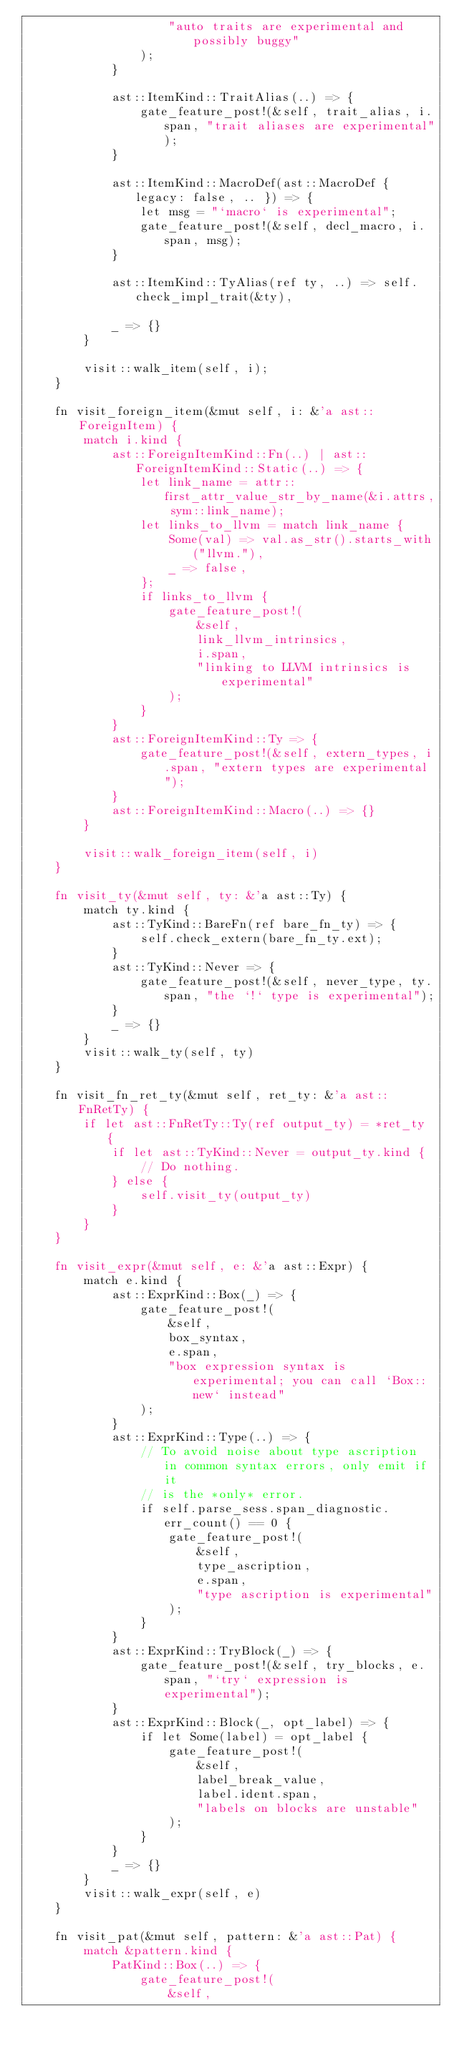Convert code to text. <code><loc_0><loc_0><loc_500><loc_500><_Rust_>                    "auto traits are experimental and possibly buggy"
                );
            }

            ast::ItemKind::TraitAlias(..) => {
                gate_feature_post!(&self, trait_alias, i.span, "trait aliases are experimental");
            }

            ast::ItemKind::MacroDef(ast::MacroDef { legacy: false, .. }) => {
                let msg = "`macro` is experimental";
                gate_feature_post!(&self, decl_macro, i.span, msg);
            }

            ast::ItemKind::TyAlias(ref ty, ..) => self.check_impl_trait(&ty),

            _ => {}
        }

        visit::walk_item(self, i);
    }

    fn visit_foreign_item(&mut self, i: &'a ast::ForeignItem) {
        match i.kind {
            ast::ForeignItemKind::Fn(..) | ast::ForeignItemKind::Static(..) => {
                let link_name = attr::first_attr_value_str_by_name(&i.attrs, sym::link_name);
                let links_to_llvm = match link_name {
                    Some(val) => val.as_str().starts_with("llvm."),
                    _ => false,
                };
                if links_to_llvm {
                    gate_feature_post!(
                        &self,
                        link_llvm_intrinsics,
                        i.span,
                        "linking to LLVM intrinsics is experimental"
                    );
                }
            }
            ast::ForeignItemKind::Ty => {
                gate_feature_post!(&self, extern_types, i.span, "extern types are experimental");
            }
            ast::ForeignItemKind::Macro(..) => {}
        }

        visit::walk_foreign_item(self, i)
    }

    fn visit_ty(&mut self, ty: &'a ast::Ty) {
        match ty.kind {
            ast::TyKind::BareFn(ref bare_fn_ty) => {
                self.check_extern(bare_fn_ty.ext);
            }
            ast::TyKind::Never => {
                gate_feature_post!(&self, never_type, ty.span, "the `!` type is experimental");
            }
            _ => {}
        }
        visit::walk_ty(self, ty)
    }

    fn visit_fn_ret_ty(&mut self, ret_ty: &'a ast::FnRetTy) {
        if let ast::FnRetTy::Ty(ref output_ty) = *ret_ty {
            if let ast::TyKind::Never = output_ty.kind {
                // Do nothing.
            } else {
                self.visit_ty(output_ty)
            }
        }
    }

    fn visit_expr(&mut self, e: &'a ast::Expr) {
        match e.kind {
            ast::ExprKind::Box(_) => {
                gate_feature_post!(
                    &self,
                    box_syntax,
                    e.span,
                    "box expression syntax is experimental; you can call `Box::new` instead"
                );
            }
            ast::ExprKind::Type(..) => {
                // To avoid noise about type ascription in common syntax errors, only emit if it
                // is the *only* error.
                if self.parse_sess.span_diagnostic.err_count() == 0 {
                    gate_feature_post!(
                        &self,
                        type_ascription,
                        e.span,
                        "type ascription is experimental"
                    );
                }
            }
            ast::ExprKind::TryBlock(_) => {
                gate_feature_post!(&self, try_blocks, e.span, "`try` expression is experimental");
            }
            ast::ExprKind::Block(_, opt_label) => {
                if let Some(label) = opt_label {
                    gate_feature_post!(
                        &self,
                        label_break_value,
                        label.ident.span,
                        "labels on blocks are unstable"
                    );
                }
            }
            _ => {}
        }
        visit::walk_expr(self, e)
    }

    fn visit_pat(&mut self, pattern: &'a ast::Pat) {
        match &pattern.kind {
            PatKind::Box(..) => {
                gate_feature_post!(
                    &self,</code> 